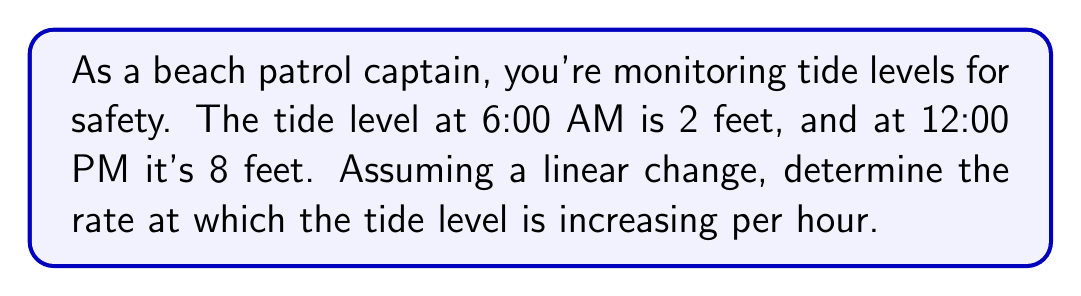Give your solution to this math problem. Let's approach this step-by-step:

1) We can represent the tide level as a linear function of time:
   $y = mx + b$, where
   $y$ is the tide level in feet
   $m$ is the rate of change (what we're looking for)
   $x$ is the time in hours since 6:00 AM
   $b$ is the initial tide level at 6:00 AM

2) We know two points on this line:
   At 6:00 AM (x = 0): y = 2 feet
   At 12:00 PM (x = 6): y = 8 feet

3) We can use the point-slope form of a line to find the rate of change:

   $m = \frac{y_2 - y_1}{x_2 - x_1}$

4) Plugging in our values:

   $m = \frac{8 - 2}{6 - 0} = \frac{6}{6} = 1$

5) Therefore, the tide level is increasing at a rate of 1 foot per hour.

6) We can verify this by writing our linear function:
   $y = 1x + 2$

   This means the tide level increases by 1 foot for each hour that passes, starting from 2 feet at 6:00 AM.
Answer: 1 foot per hour 